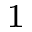Convert formula to latex. <formula><loc_0><loc_0><loc_500><loc_500>^ { 1 }</formula> 